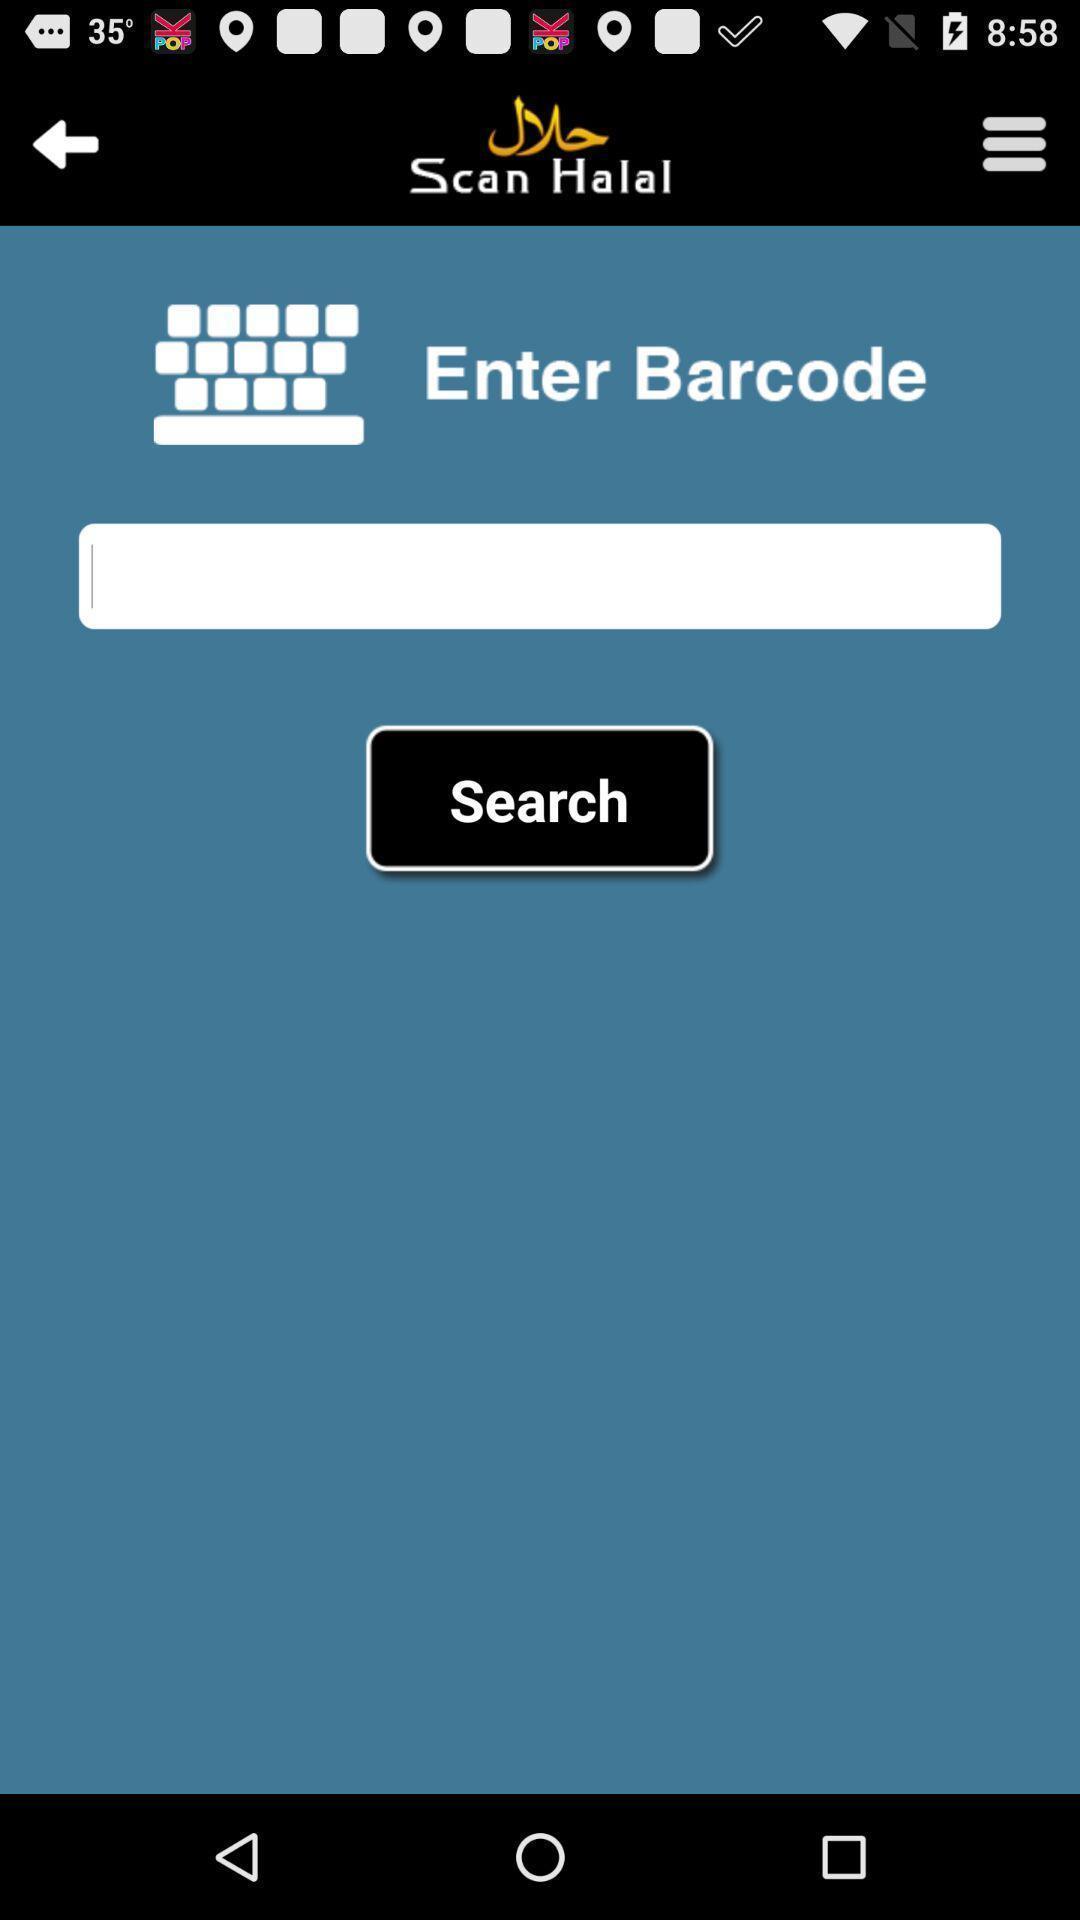Describe the visual elements of this screenshot. Screen showing enter bar code option to find halal foods. 